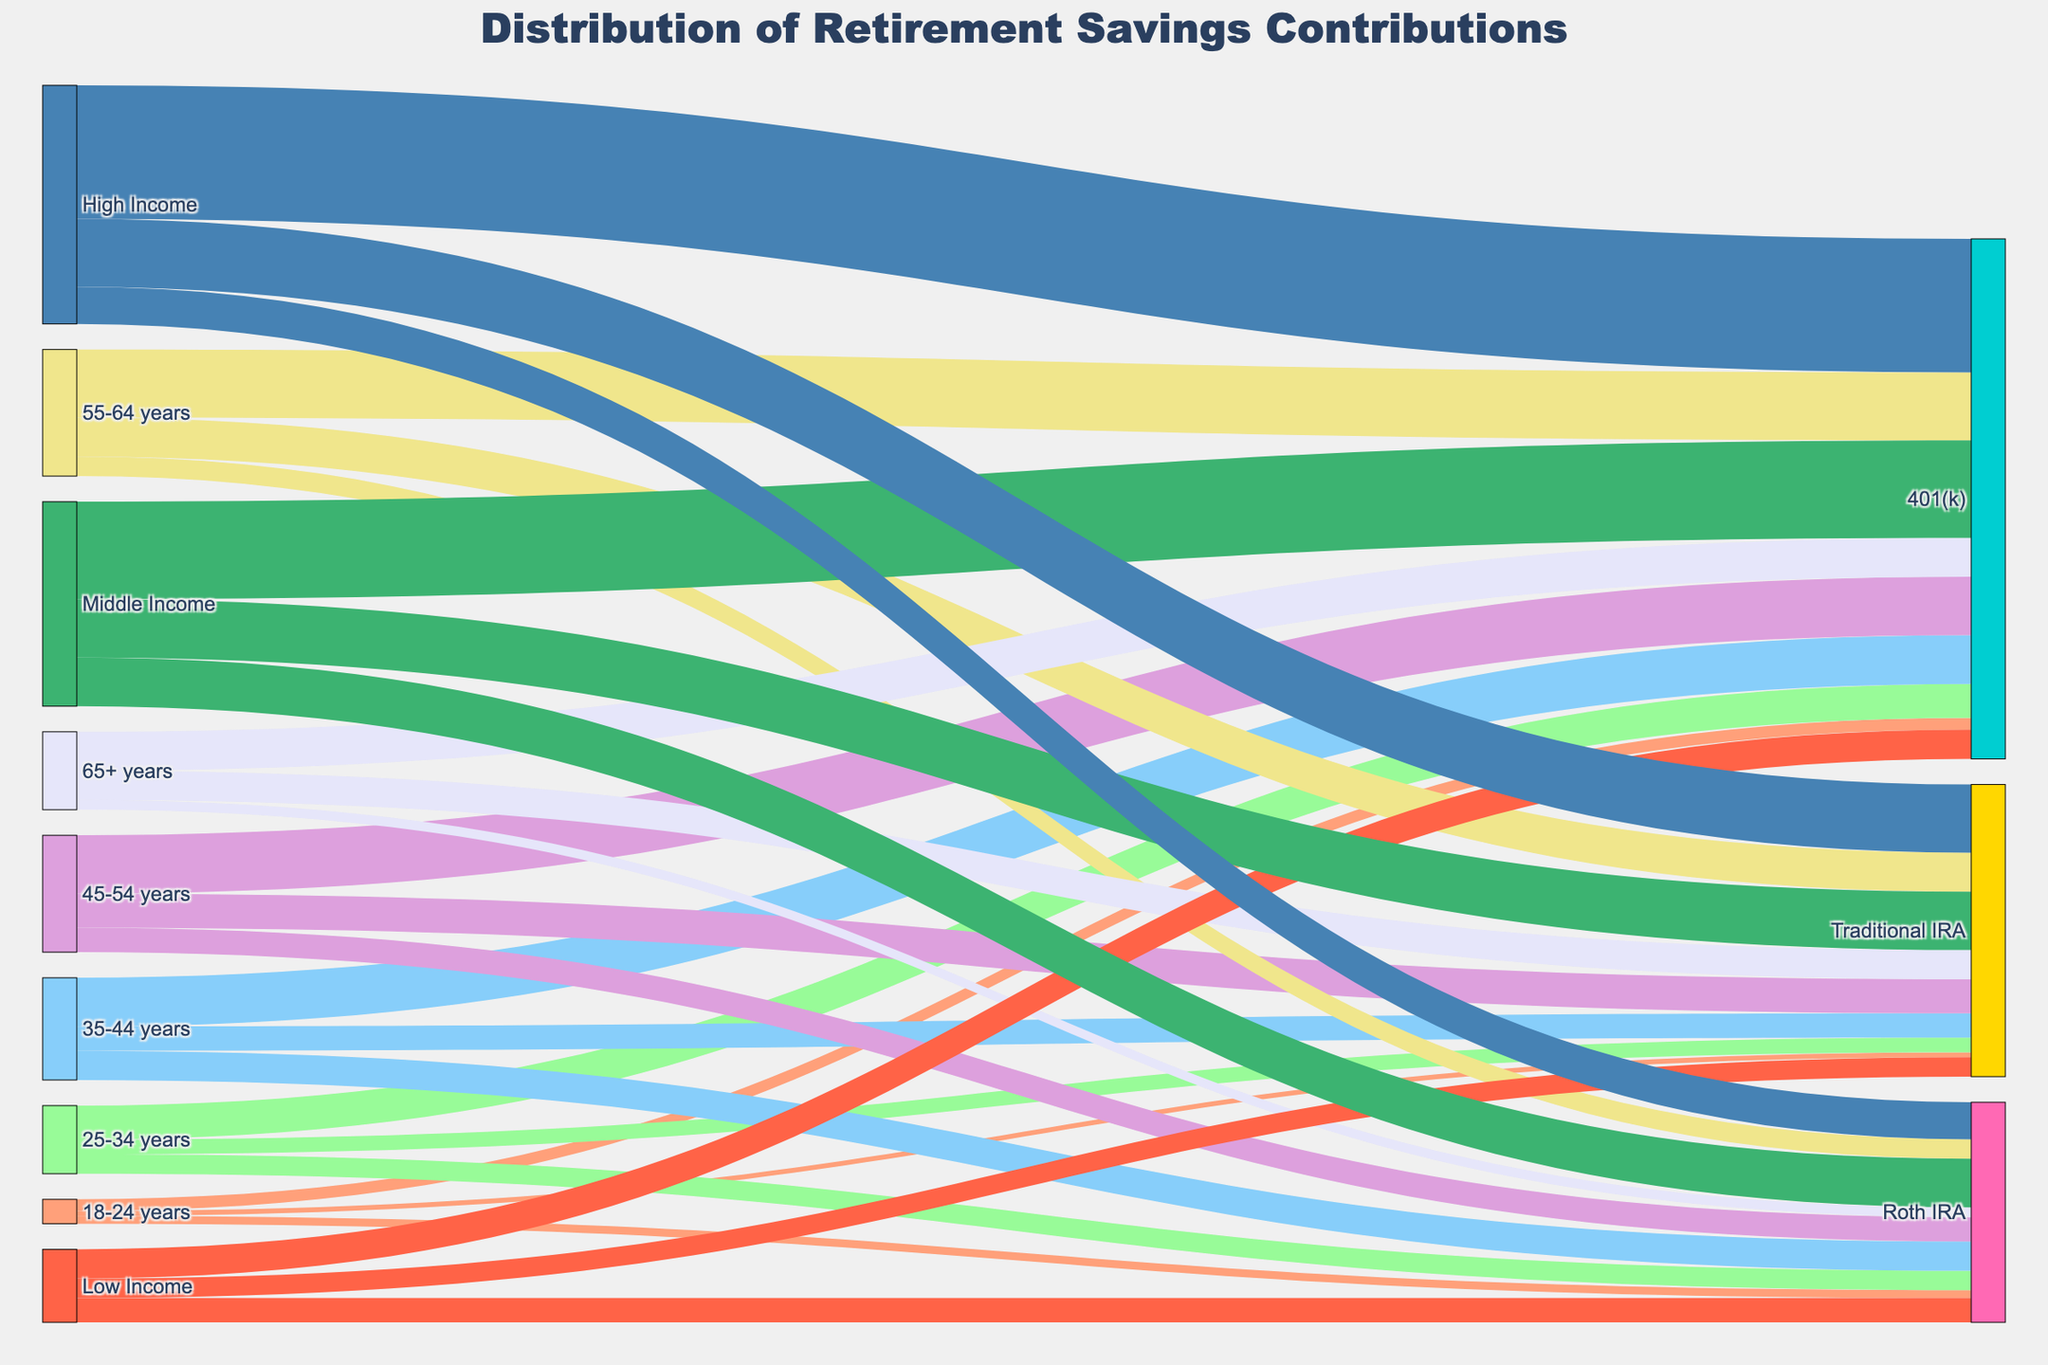What is the largest contribution to Traditional IRAs by any age group? Look at the values for Traditional IRAs by age group and identify the highest value. The highest contribution is made by the 55-64 years age group with a value of 40.
Answer: 40 Which income level has the highest total contribution across all retirement accounts? Add the values of contributions to Traditional IRA, Roth IRA, and 401(k) for each income level. The totals are 75 (Low Income), 210 (Middle Income), and 245 (High Income). High Income has the highest total contribution.
Answer: High Income What is the contribution amount from the 35-44 years age group to 401(k) accounts? Identify the value connected to the 35-44 years age group and the 401(k) target. The value is 50.
Answer: 50 How does the contribution to Roth IRAs by the 25-34 years age group compare to the 45-54 years age group? Compare the values of Roth IRA contributions by the two age groups: 20 (25-34 years) and 25 (45-54 years). The contribution by the 45-54 years age group is higher.
Answer: The 45-54 years age group contributes 5 more What is the total contribution to 401(k) accounts by all age groups combined? Add the values of contributions to 401(k) from all age groups: 12 (18-24 years) + 35 (25-34 years) + 50 (35-44 years) + 60 (45-54 years) + 70 (55-64 years) + 40 (65+ years). The total is 267.
Answer: 267 Which retirement account receives the highest total contributions from Low Income and Middle Income combined? Examine the contributions to each retirement account from Low Income (20 Traditional IRA, 25 Roth IRA, 30 401(k)) and Middle Income (60 Traditional IRA, 50 Roth IRA, 100 401(k)). The combined values are 80 (Traditional IRA), 75 (Roth IRA), and 130 (401(k)). 401(k) has the highest total.
Answer: 401(k) What is the difference between High Income contributions to Traditional IRAs and Roth IRAs? Subtract the value of Roth IRA contributions from the value of Traditional IRA contributions by High Income. It is 70 (Traditional IRA) - 38 (Roth IRA) = 32.
Answer: 32 How do contributions to Roth IRAs compare between Low Income and High Income groups? Compare the values of Roth IRA contributions from Low Income (25) and High Income (38). High Income contributes more.
Answer: High Income contributes more by 13 